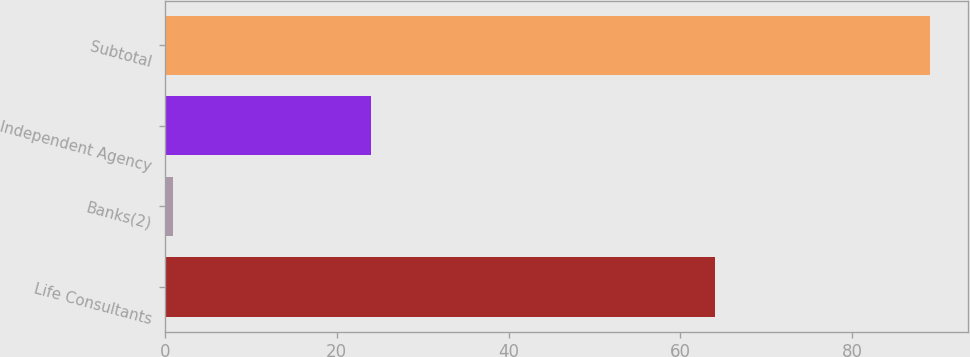Convert chart. <chart><loc_0><loc_0><loc_500><loc_500><bar_chart><fcel>Life Consultants<fcel>Banks(2)<fcel>Independent Agency<fcel>Subtotal<nl><fcel>64<fcel>1<fcel>24<fcel>89<nl></chart> 